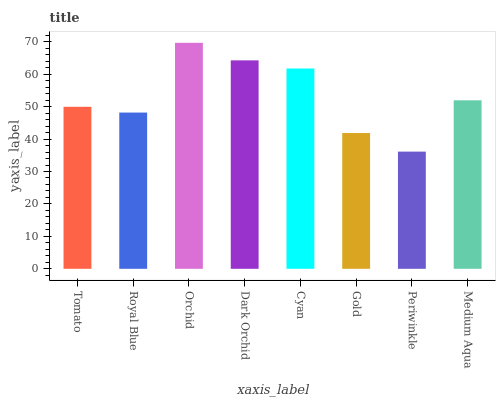Is Royal Blue the minimum?
Answer yes or no. No. Is Royal Blue the maximum?
Answer yes or no. No. Is Tomato greater than Royal Blue?
Answer yes or no. Yes. Is Royal Blue less than Tomato?
Answer yes or no. Yes. Is Royal Blue greater than Tomato?
Answer yes or no. No. Is Tomato less than Royal Blue?
Answer yes or no. No. Is Medium Aqua the high median?
Answer yes or no. Yes. Is Tomato the low median?
Answer yes or no. Yes. Is Gold the high median?
Answer yes or no. No. Is Orchid the low median?
Answer yes or no. No. 